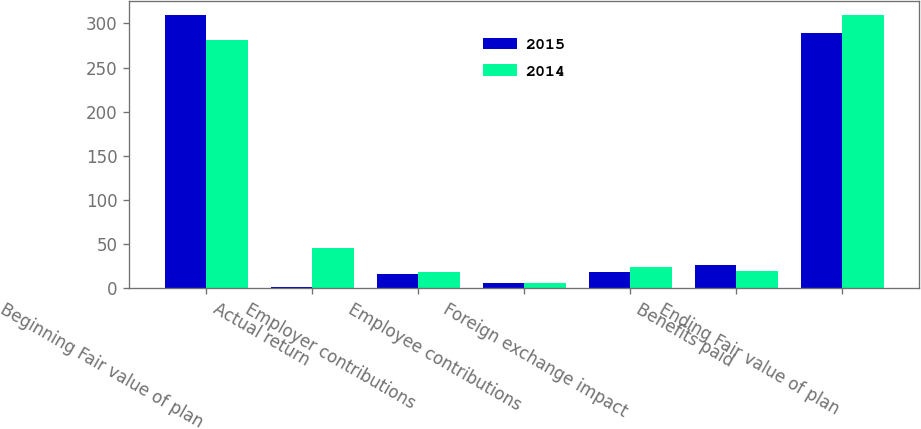Convert chart. <chart><loc_0><loc_0><loc_500><loc_500><stacked_bar_chart><ecel><fcel>Beginning Fair value of plan<fcel>Actual return<fcel>Employer contributions<fcel>Employee contributions<fcel>Foreign exchange impact<fcel>Benefits paid<fcel>Ending Fair value of plan<nl><fcel>2015<fcel>310<fcel>2<fcel>16<fcel>6<fcel>18<fcel>27<fcel>289<nl><fcel>2014<fcel>281<fcel>46<fcel>18<fcel>6<fcel>24<fcel>20<fcel>310<nl></chart> 